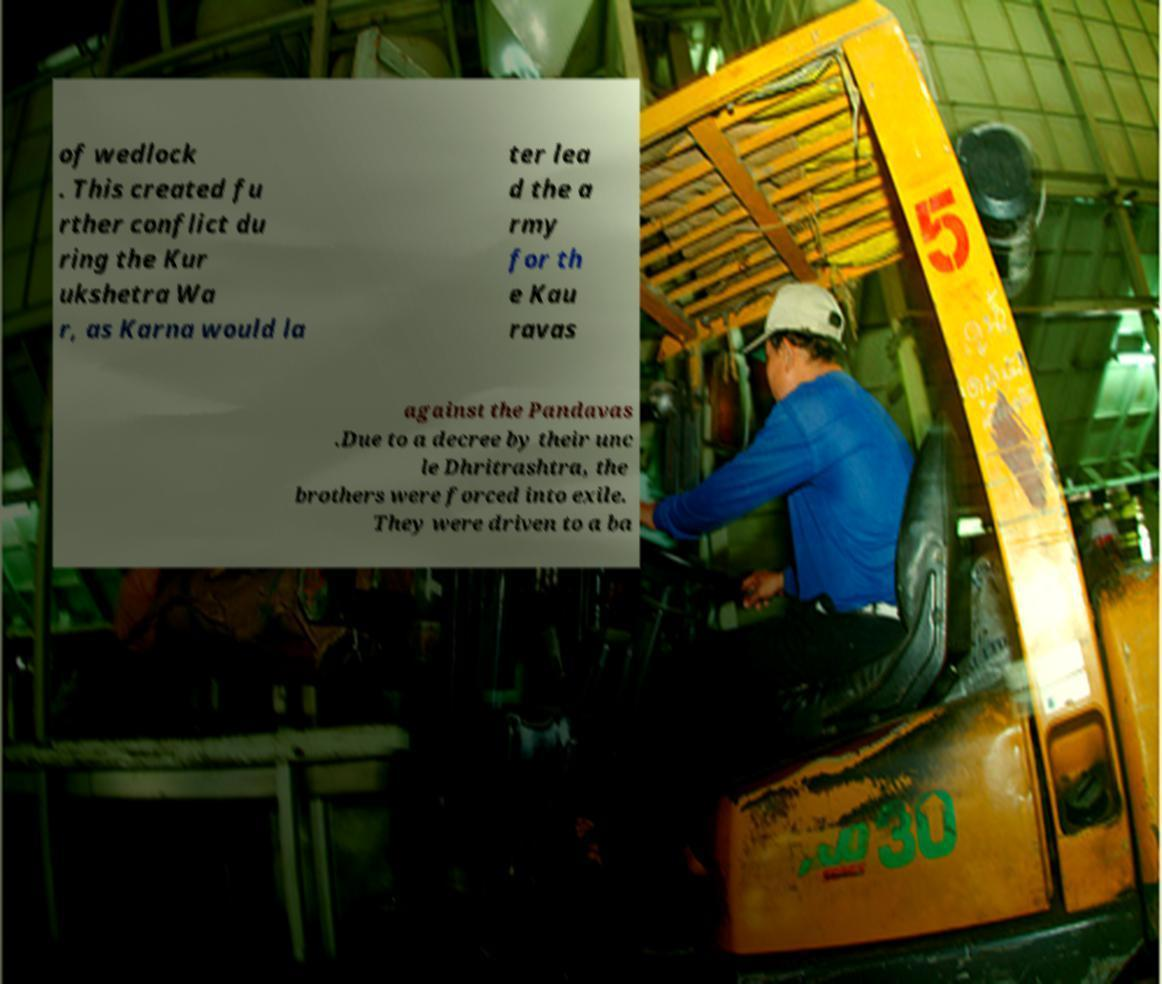Can you accurately transcribe the text from the provided image for me? of wedlock . This created fu rther conflict du ring the Kur ukshetra Wa r, as Karna would la ter lea d the a rmy for th e Kau ravas against the Pandavas .Due to a decree by their unc le Dhritrashtra, the brothers were forced into exile. They were driven to a ba 